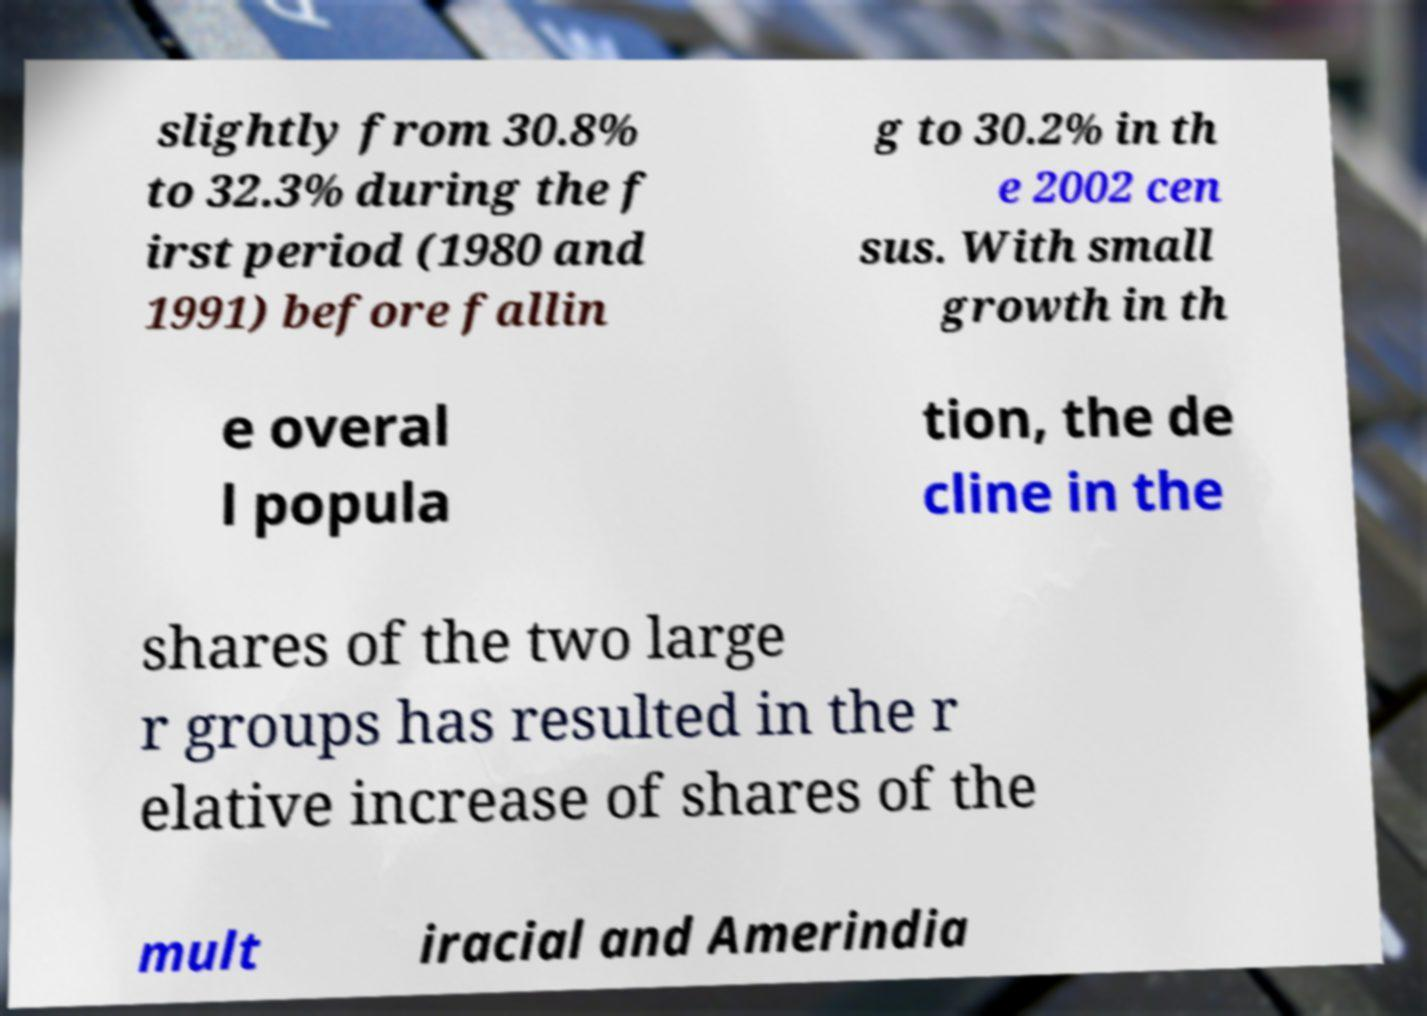Please identify and transcribe the text found in this image. slightly from 30.8% to 32.3% during the f irst period (1980 and 1991) before fallin g to 30.2% in th e 2002 cen sus. With small growth in th e overal l popula tion, the de cline in the shares of the two large r groups has resulted in the r elative increase of shares of the mult iracial and Amerindia 